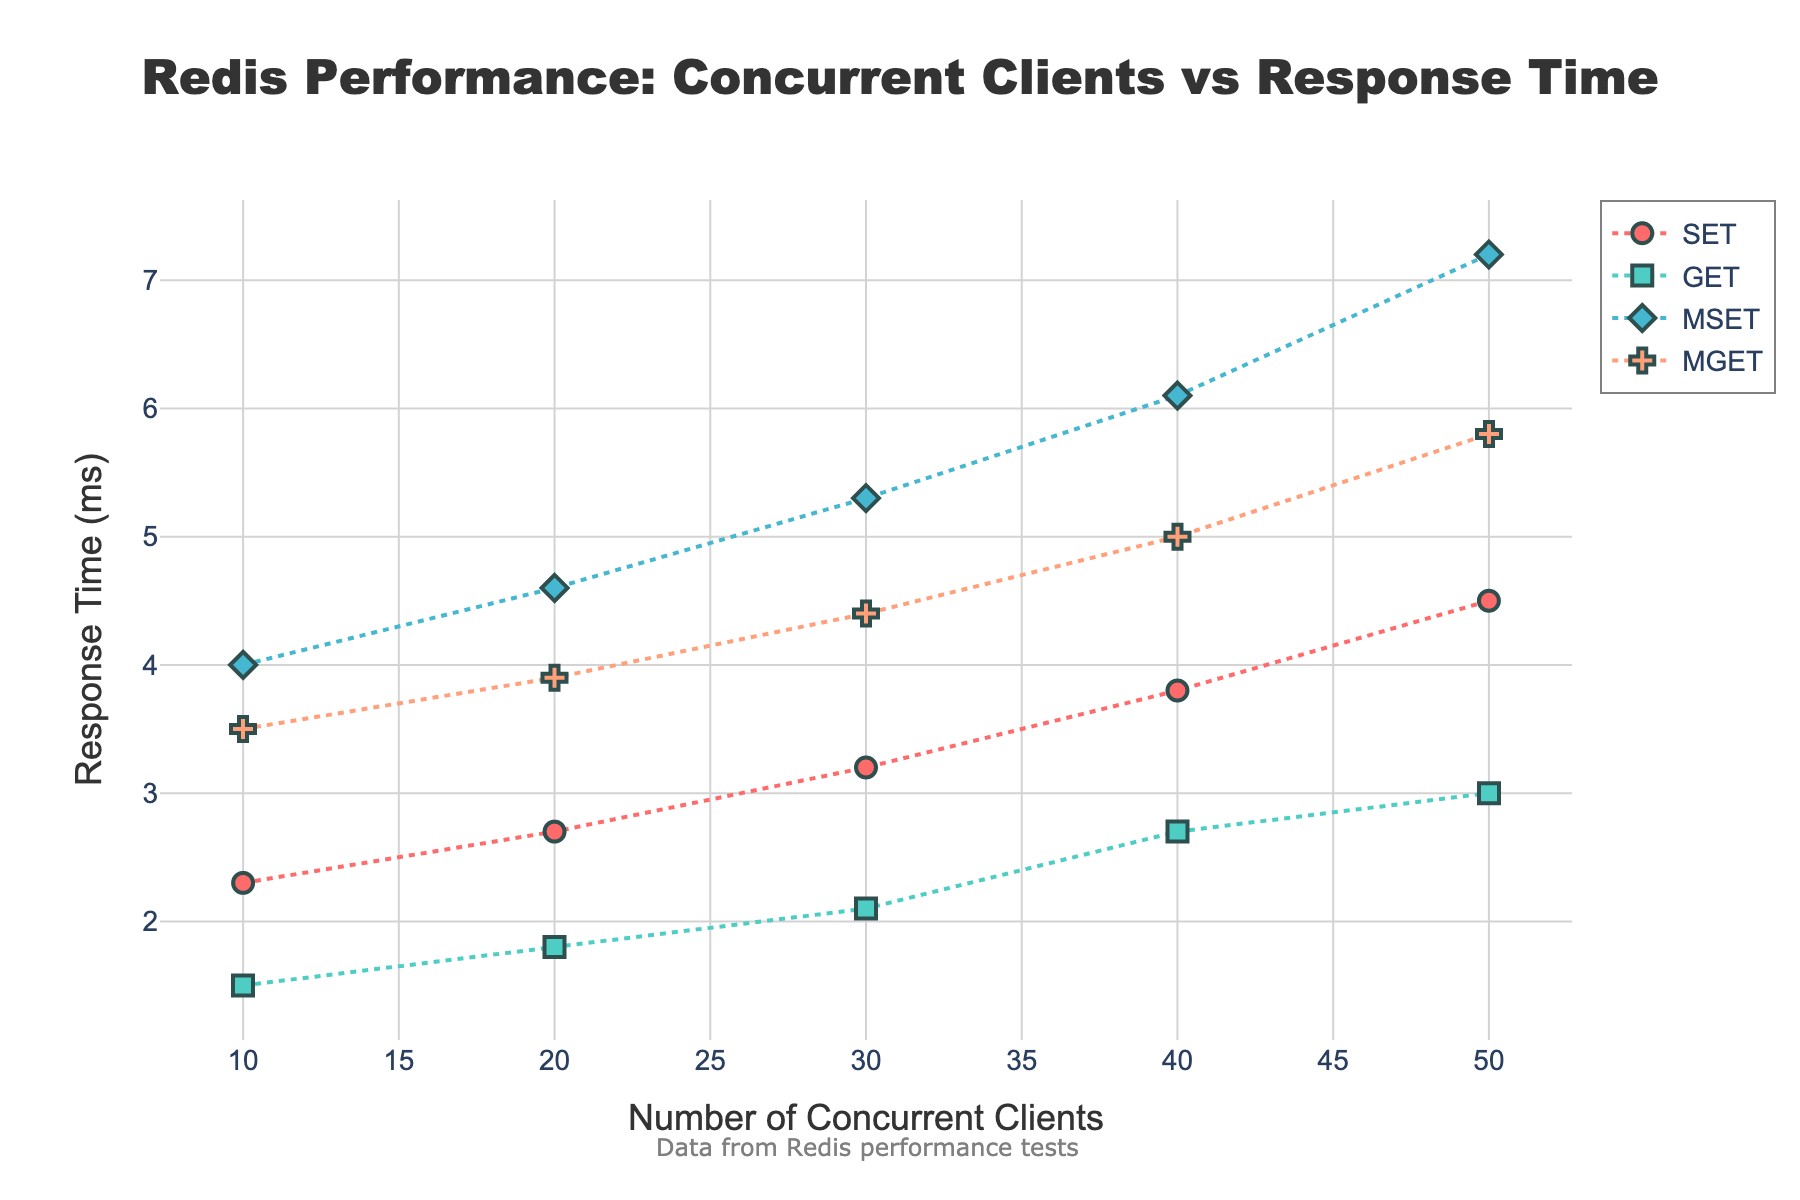How many different operation types are shown in the plot? The plot shows the traces for 4 distinct operation types indicated by different markers and colors. The legend in the plot lists SET, GET, MSET, and MGET as the operation types.
Answer: 4 Which operation type has the highest response time at 50 concurrent clients? To find this, we look at the points associated with 50 concurrent clients and compare the y-axis values. The highest response time at this client count is shown by the MSET operation type.
Answer: MSET What can be inferred about the relationship between the response time and the number of concurrent clients for the GET operation? Observing the plot, the points for GET operations show an increasing trend along the y-axis as the client count increases from 10 to 50. This indicates that the response time increases with the number of concurrent clients.
Answer: Response time increases with more clients Which operation type has the steepest increase in response time as the number of concurrent clients increases? By visually comparing the slopes of the lines representing each operation type, MSET shows the steepest slope. This indicates MSET has the most significant increase in response time as the client count increases.
Answer: MSET At 20 concurrent clients, which operation type has the lowest response time, and what is the value? To find the operation type with the lowest response time at 20 concurrent clients, we check the y-axis values for x = 20. GET has the lowest response time at this point with a value of 1.8 ms.
Answer: GET, 1.8 ms Compare the response times for MGET and SET operations at 30 clients. Which one is lower? By checking the plot at 30 concurrent clients for both MGET and SET, we see that the MGET operation has a response time of 4.4 ms, while the SET operation has a response time of 3.2 ms. Thus, SET has a lower response time.
Answer: SET What is the difference in response time between MSET and MGET at 40 concurrent clients? For 40 concurrent clients, the response time for MSET is 6.1 ms, and for MGET, it is 5.0 ms. The difference is 6.1 ms - 5.0 ms = 1.1 ms.
Answer: 1.1 ms For which operation type does the response time remain under 3 ms, and up to how many concurrent clients does this occur? We observe the y-axis values for each operation type and see that the GET operation maintains a response time under 3 ms up to 30 concurrent clients.
Answer: GET, up to 30 clients What’s the average response time for SET operation across all client counts? The response times for SET operation at given client counts are: 2.3, 2.7, 3.2, 3.8, and 4.5 ms. Adding these values and dividing by 5: (2.3 + 2.7 + 3.2 + 3.8 + 4.5) / 5 = 16.5 / 5 = 3.3 ms.
Answer: 3.3 ms 